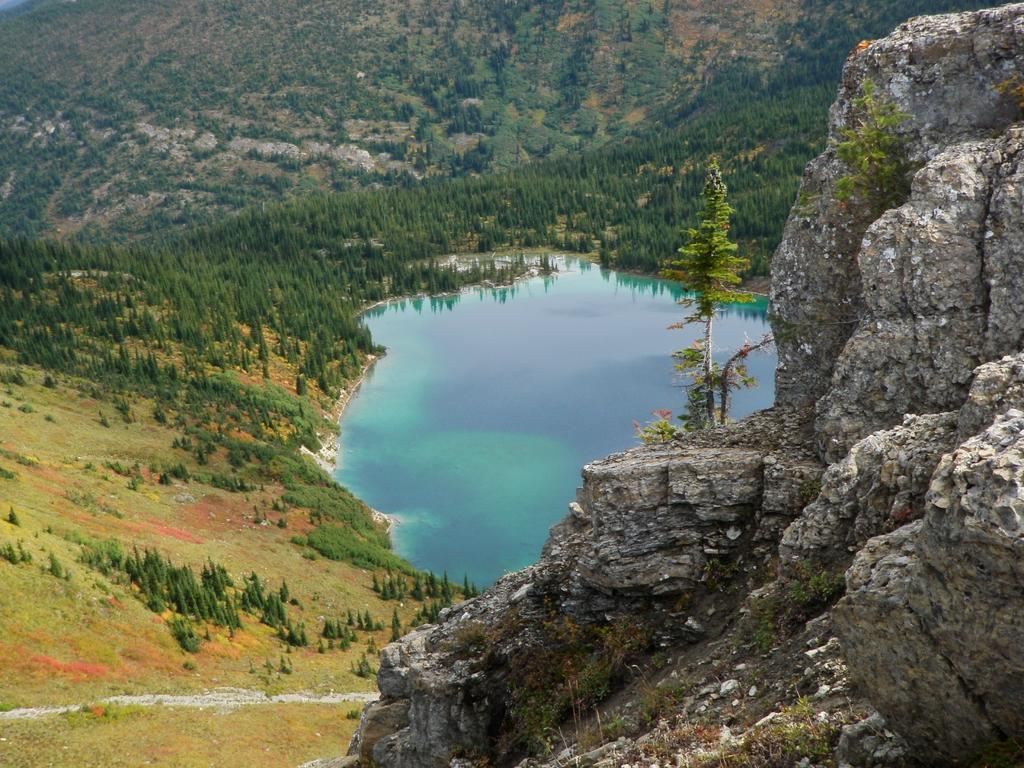What type of body of water is present in the image? There is a small lake in the image. What type of vegetation can be seen in the image? There are trees on the ground in the image. What can be seen in the distance in the image? There is a hill visible in the background of the image. Can you see any tanks in the image? There are no tanks present in the image. 